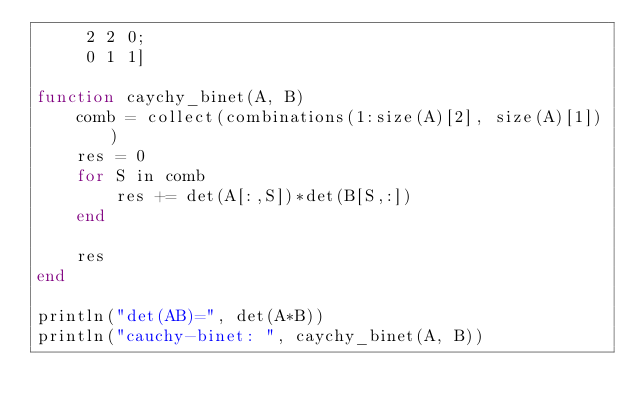<code> <loc_0><loc_0><loc_500><loc_500><_Julia_>     2 2 0;
     0 1 1]

function caychy_binet(A, B)
    comb = collect(combinations(1:size(A)[2], size(A)[1]))
    res = 0
    for S in comb
        res += det(A[:,S])*det(B[S,:])
    end

    res
end

println("det(AB)=", det(A*B))
println("cauchy-binet: ", caychy_binet(A, B))</code> 